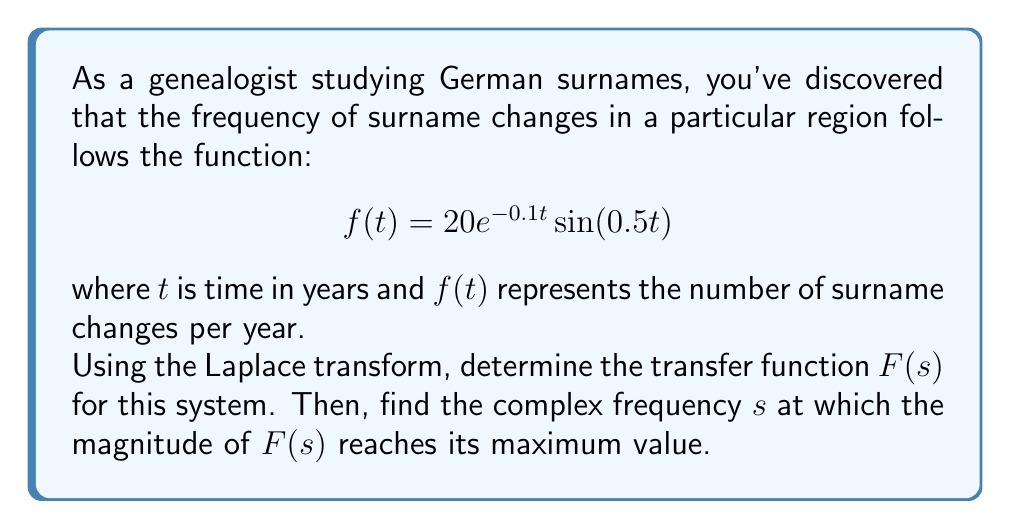Teach me how to tackle this problem. 1) First, we need to calculate the Laplace transform of $f(t)$. The Laplace transform of $e^{at}\sin(bt)$ is given by:

   $$\mathcal{L}\{e^{at}\sin(bt)\} = \frac{b}{(s-a)^2 + b^2}$$

2) In our case, $a = -0.1$ and $b = 0.5$. We also have a constant factor of 20. So:

   $$F(s) = 20 \cdot \frac{0.5}{(s+0.1)^2 + 0.5^2}$$

3) Simplifying:

   $$F(s) = \frac{10}{(s+0.1)^2 + 0.25}$$

4) To find the maximum magnitude, we need to find where $|F(s)|$ is maximum. The magnitude is given by:

   $$|F(s)| = \frac{10}{\sqrt{((s+0.1)^2 + 0.25)^2}}$$

5) This will be maximum when the denominator is minimum. The denominator is minimum when $s = -0.1$, as this makes the $(s+0.1)^2$ term zero.

6) Therefore, the complex frequency $s$ at which $|F(s)|$ reaches its maximum is $s = -0.1$.
Answer: $s = -0.1$ 